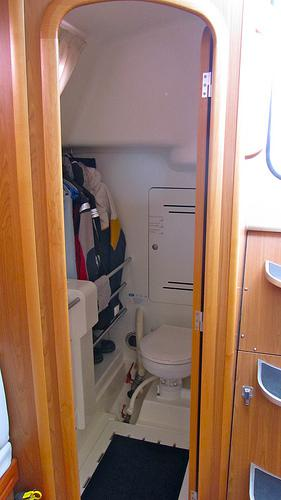Question: how many blue shelves are there?
Choices:
A. One.
B. Three.
C. Two.
D. Four.
Answer with the letter. Answer: B 